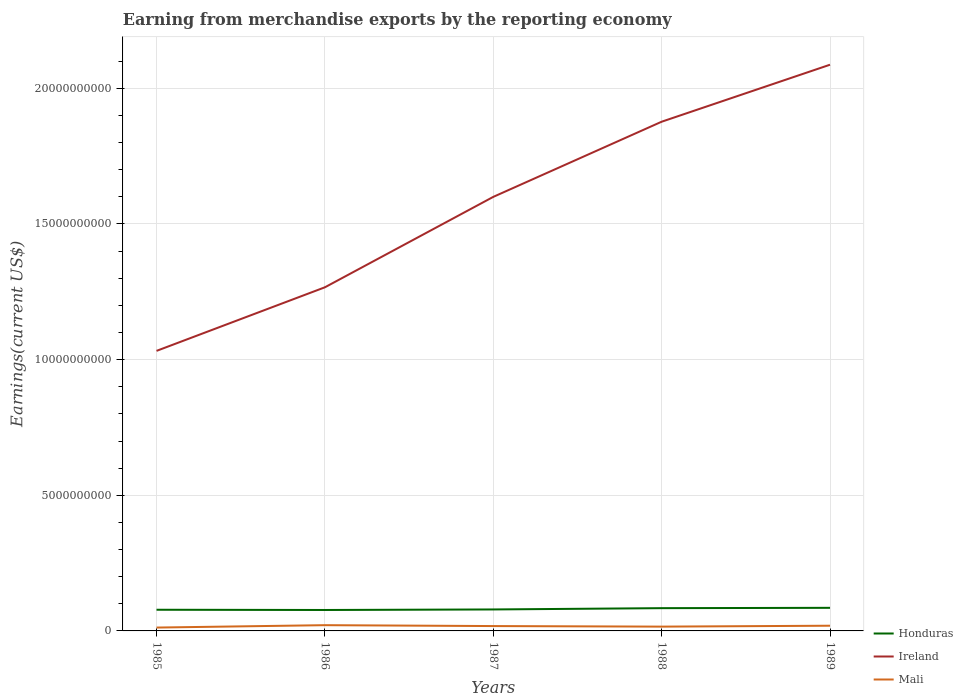Across all years, what is the maximum amount earned from merchandise exports in Ireland?
Provide a succinct answer. 1.03e+1. In which year was the amount earned from merchandise exports in Ireland maximum?
Ensure brevity in your answer.  1985. What is the total amount earned from merchandise exports in Honduras in the graph?
Provide a succinct answer. 8.28e+06. What is the difference between the highest and the second highest amount earned from merchandise exports in Mali?
Keep it short and to the point. 8.81e+07. What is the difference between the highest and the lowest amount earned from merchandise exports in Honduras?
Provide a succinct answer. 2. Is the amount earned from merchandise exports in Ireland strictly greater than the amount earned from merchandise exports in Honduras over the years?
Make the answer very short. No. How many lines are there?
Give a very brief answer. 3. What is the difference between two consecutive major ticks on the Y-axis?
Your response must be concise. 5.00e+09. Are the values on the major ticks of Y-axis written in scientific E-notation?
Your answer should be very brief. No. Does the graph contain any zero values?
Provide a short and direct response. No. Where does the legend appear in the graph?
Provide a succinct answer. Bottom right. How many legend labels are there?
Offer a very short reply. 3. What is the title of the graph?
Offer a very short reply. Earning from merchandise exports by the reporting economy. What is the label or title of the X-axis?
Make the answer very short. Years. What is the label or title of the Y-axis?
Your response must be concise. Earnings(current US$). What is the Earnings(current US$) of Honduras in 1985?
Offer a very short reply. 7.80e+08. What is the Earnings(current US$) of Ireland in 1985?
Your answer should be very brief. 1.03e+1. What is the Earnings(current US$) in Mali in 1985?
Your response must be concise. 1.24e+08. What is the Earnings(current US$) of Honduras in 1986?
Keep it short and to the point. 7.72e+08. What is the Earnings(current US$) in Ireland in 1986?
Your answer should be compact. 1.27e+1. What is the Earnings(current US$) in Mali in 1986?
Make the answer very short. 2.12e+08. What is the Earnings(current US$) of Honduras in 1987?
Keep it short and to the point. 7.91e+08. What is the Earnings(current US$) in Ireland in 1987?
Give a very brief answer. 1.60e+1. What is the Earnings(current US$) in Mali in 1987?
Provide a short and direct response. 1.79e+08. What is the Earnings(current US$) of Honduras in 1988?
Provide a succinct answer. 8.39e+08. What is the Earnings(current US$) of Ireland in 1988?
Make the answer very short. 1.88e+1. What is the Earnings(current US$) of Mali in 1988?
Give a very brief answer. 1.58e+08. What is the Earnings(current US$) of Honduras in 1989?
Offer a very short reply. 8.51e+08. What is the Earnings(current US$) of Ireland in 1989?
Keep it short and to the point. 2.09e+1. What is the Earnings(current US$) of Mali in 1989?
Ensure brevity in your answer.  1.92e+08. Across all years, what is the maximum Earnings(current US$) of Honduras?
Provide a short and direct response. 8.51e+08. Across all years, what is the maximum Earnings(current US$) in Ireland?
Your answer should be very brief. 2.09e+1. Across all years, what is the maximum Earnings(current US$) of Mali?
Give a very brief answer. 2.12e+08. Across all years, what is the minimum Earnings(current US$) of Honduras?
Provide a short and direct response. 7.72e+08. Across all years, what is the minimum Earnings(current US$) in Ireland?
Offer a terse response. 1.03e+1. Across all years, what is the minimum Earnings(current US$) in Mali?
Make the answer very short. 1.24e+08. What is the total Earnings(current US$) of Honduras in the graph?
Give a very brief answer. 4.03e+09. What is the total Earnings(current US$) of Ireland in the graph?
Make the answer very short. 7.86e+1. What is the total Earnings(current US$) in Mali in the graph?
Make the answer very short. 8.64e+08. What is the difference between the Earnings(current US$) of Honduras in 1985 and that in 1986?
Give a very brief answer. 8.28e+06. What is the difference between the Earnings(current US$) of Ireland in 1985 and that in 1986?
Provide a short and direct response. -2.34e+09. What is the difference between the Earnings(current US$) in Mali in 1985 and that in 1986?
Provide a succinct answer. -8.81e+07. What is the difference between the Earnings(current US$) in Honduras in 1985 and that in 1987?
Your response must be concise. -1.13e+07. What is the difference between the Earnings(current US$) in Ireland in 1985 and that in 1987?
Your response must be concise. -5.68e+09. What is the difference between the Earnings(current US$) of Mali in 1985 and that in 1987?
Give a very brief answer. -5.53e+07. What is the difference between the Earnings(current US$) of Honduras in 1985 and that in 1988?
Keep it short and to the point. -5.89e+07. What is the difference between the Earnings(current US$) in Ireland in 1985 and that in 1988?
Make the answer very short. -8.45e+09. What is the difference between the Earnings(current US$) in Mali in 1985 and that in 1988?
Your response must be concise. -3.46e+07. What is the difference between the Earnings(current US$) of Honduras in 1985 and that in 1989?
Provide a succinct answer. -7.09e+07. What is the difference between the Earnings(current US$) of Ireland in 1985 and that in 1989?
Provide a succinct answer. -1.05e+1. What is the difference between the Earnings(current US$) of Mali in 1985 and that in 1989?
Make the answer very short. -6.81e+07. What is the difference between the Earnings(current US$) of Honduras in 1986 and that in 1987?
Provide a short and direct response. -1.96e+07. What is the difference between the Earnings(current US$) of Ireland in 1986 and that in 1987?
Provide a short and direct response. -3.33e+09. What is the difference between the Earnings(current US$) in Mali in 1986 and that in 1987?
Keep it short and to the point. 3.28e+07. What is the difference between the Earnings(current US$) of Honduras in 1986 and that in 1988?
Offer a very short reply. -6.72e+07. What is the difference between the Earnings(current US$) of Ireland in 1986 and that in 1988?
Ensure brevity in your answer.  -6.10e+09. What is the difference between the Earnings(current US$) in Mali in 1986 and that in 1988?
Provide a short and direct response. 5.35e+07. What is the difference between the Earnings(current US$) in Honduras in 1986 and that in 1989?
Provide a succinct answer. -7.92e+07. What is the difference between the Earnings(current US$) of Ireland in 1986 and that in 1989?
Provide a short and direct response. -8.20e+09. What is the difference between the Earnings(current US$) in Mali in 1986 and that in 1989?
Offer a very short reply. 2.00e+07. What is the difference between the Earnings(current US$) in Honduras in 1987 and that in 1988?
Your answer should be compact. -4.76e+07. What is the difference between the Earnings(current US$) in Ireland in 1987 and that in 1988?
Your response must be concise. -2.77e+09. What is the difference between the Earnings(current US$) in Mali in 1987 and that in 1988?
Keep it short and to the point. 2.07e+07. What is the difference between the Earnings(current US$) in Honduras in 1987 and that in 1989?
Ensure brevity in your answer.  -5.96e+07. What is the difference between the Earnings(current US$) of Ireland in 1987 and that in 1989?
Give a very brief answer. -4.87e+09. What is the difference between the Earnings(current US$) of Mali in 1987 and that in 1989?
Your response must be concise. -1.28e+07. What is the difference between the Earnings(current US$) in Honduras in 1988 and that in 1989?
Provide a succinct answer. -1.20e+07. What is the difference between the Earnings(current US$) in Ireland in 1988 and that in 1989?
Ensure brevity in your answer.  -2.10e+09. What is the difference between the Earnings(current US$) of Mali in 1988 and that in 1989?
Provide a short and direct response. -3.35e+07. What is the difference between the Earnings(current US$) of Honduras in 1985 and the Earnings(current US$) of Ireland in 1986?
Your response must be concise. -1.19e+1. What is the difference between the Earnings(current US$) of Honduras in 1985 and the Earnings(current US$) of Mali in 1986?
Your response must be concise. 5.68e+08. What is the difference between the Earnings(current US$) of Ireland in 1985 and the Earnings(current US$) of Mali in 1986?
Your answer should be compact. 1.01e+1. What is the difference between the Earnings(current US$) of Honduras in 1985 and the Earnings(current US$) of Ireland in 1987?
Keep it short and to the point. -1.52e+1. What is the difference between the Earnings(current US$) of Honduras in 1985 and the Earnings(current US$) of Mali in 1987?
Give a very brief answer. 6.01e+08. What is the difference between the Earnings(current US$) of Ireland in 1985 and the Earnings(current US$) of Mali in 1987?
Provide a short and direct response. 1.01e+1. What is the difference between the Earnings(current US$) of Honduras in 1985 and the Earnings(current US$) of Ireland in 1988?
Provide a succinct answer. -1.80e+1. What is the difference between the Earnings(current US$) of Honduras in 1985 and the Earnings(current US$) of Mali in 1988?
Make the answer very short. 6.22e+08. What is the difference between the Earnings(current US$) of Ireland in 1985 and the Earnings(current US$) of Mali in 1988?
Your answer should be compact. 1.02e+1. What is the difference between the Earnings(current US$) in Honduras in 1985 and the Earnings(current US$) in Ireland in 1989?
Keep it short and to the point. -2.01e+1. What is the difference between the Earnings(current US$) in Honduras in 1985 and the Earnings(current US$) in Mali in 1989?
Provide a short and direct response. 5.88e+08. What is the difference between the Earnings(current US$) in Ireland in 1985 and the Earnings(current US$) in Mali in 1989?
Provide a succinct answer. 1.01e+1. What is the difference between the Earnings(current US$) of Honduras in 1986 and the Earnings(current US$) of Ireland in 1987?
Ensure brevity in your answer.  -1.52e+1. What is the difference between the Earnings(current US$) of Honduras in 1986 and the Earnings(current US$) of Mali in 1987?
Your answer should be very brief. 5.93e+08. What is the difference between the Earnings(current US$) in Ireland in 1986 and the Earnings(current US$) in Mali in 1987?
Offer a very short reply. 1.25e+1. What is the difference between the Earnings(current US$) of Honduras in 1986 and the Earnings(current US$) of Ireland in 1988?
Ensure brevity in your answer.  -1.80e+1. What is the difference between the Earnings(current US$) of Honduras in 1986 and the Earnings(current US$) of Mali in 1988?
Offer a very short reply. 6.14e+08. What is the difference between the Earnings(current US$) of Ireland in 1986 and the Earnings(current US$) of Mali in 1988?
Your response must be concise. 1.25e+1. What is the difference between the Earnings(current US$) of Honduras in 1986 and the Earnings(current US$) of Ireland in 1989?
Keep it short and to the point. -2.01e+1. What is the difference between the Earnings(current US$) of Honduras in 1986 and the Earnings(current US$) of Mali in 1989?
Ensure brevity in your answer.  5.80e+08. What is the difference between the Earnings(current US$) of Ireland in 1986 and the Earnings(current US$) of Mali in 1989?
Your answer should be very brief. 1.25e+1. What is the difference between the Earnings(current US$) in Honduras in 1987 and the Earnings(current US$) in Ireland in 1988?
Provide a short and direct response. -1.80e+1. What is the difference between the Earnings(current US$) in Honduras in 1987 and the Earnings(current US$) in Mali in 1988?
Keep it short and to the point. 6.33e+08. What is the difference between the Earnings(current US$) of Ireland in 1987 and the Earnings(current US$) of Mali in 1988?
Keep it short and to the point. 1.58e+1. What is the difference between the Earnings(current US$) in Honduras in 1987 and the Earnings(current US$) in Ireland in 1989?
Provide a succinct answer. -2.01e+1. What is the difference between the Earnings(current US$) in Honduras in 1987 and the Earnings(current US$) in Mali in 1989?
Provide a succinct answer. 6.00e+08. What is the difference between the Earnings(current US$) in Ireland in 1987 and the Earnings(current US$) in Mali in 1989?
Make the answer very short. 1.58e+1. What is the difference between the Earnings(current US$) in Honduras in 1988 and the Earnings(current US$) in Ireland in 1989?
Give a very brief answer. -2.00e+1. What is the difference between the Earnings(current US$) of Honduras in 1988 and the Earnings(current US$) of Mali in 1989?
Offer a terse response. 6.47e+08. What is the difference between the Earnings(current US$) in Ireland in 1988 and the Earnings(current US$) in Mali in 1989?
Your response must be concise. 1.86e+1. What is the average Earnings(current US$) in Honduras per year?
Keep it short and to the point. 8.07e+08. What is the average Earnings(current US$) in Ireland per year?
Make the answer very short. 1.57e+1. What is the average Earnings(current US$) in Mali per year?
Make the answer very short. 1.73e+08. In the year 1985, what is the difference between the Earnings(current US$) in Honduras and Earnings(current US$) in Ireland?
Ensure brevity in your answer.  -9.54e+09. In the year 1985, what is the difference between the Earnings(current US$) in Honduras and Earnings(current US$) in Mali?
Offer a terse response. 6.57e+08. In the year 1985, what is the difference between the Earnings(current US$) of Ireland and Earnings(current US$) of Mali?
Make the answer very short. 1.02e+1. In the year 1986, what is the difference between the Earnings(current US$) in Honduras and Earnings(current US$) in Ireland?
Your response must be concise. -1.19e+1. In the year 1986, what is the difference between the Earnings(current US$) in Honduras and Earnings(current US$) in Mali?
Your response must be concise. 5.60e+08. In the year 1986, what is the difference between the Earnings(current US$) in Ireland and Earnings(current US$) in Mali?
Your answer should be very brief. 1.25e+1. In the year 1987, what is the difference between the Earnings(current US$) of Honduras and Earnings(current US$) of Ireland?
Provide a succinct answer. -1.52e+1. In the year 1987, what is the difference between the Earnings(current US$) of Honduras and Earnings(current US$) of Mali?
Offer a very short reply. 6.12e+08. In the year 1987, what is the difference between the Earnings(current US$) of Ireland and Earnings(current US$) of Mali?
Offer a terse response. 1.58e+1. In the year 1988, what is the difference between the Earnings(current US$) in Honduras and Earnings(current US$) in Ireland?
Your answer should be very brief. -1.79e+1. In the year 1988, what is the difference between the Earnings(current US$) of Honduras and Earnings(current US$) of Mali?
Offer a very short reply. 6.81e+08. In the year 1988, what is the difference between the Earnings(current US$) in Ireland and Earnings(current US$) in Mali?
Your answer should be compact. 1.86e+1. In the year 1989, what is the difference between the Earnings(current US$) in Honduras and Earnings(current US$) in Ireland?
Your response must be concise. -2.00e+1. In the year 1989, what is the difference between the Earnings(current US$) of Honduras and Earnings(current US$) of Mali?
Your response must be concise. 6.59e+08. In the year 1989, what is the difference between the Earnings(current US$) of Ireland and Earnings(current US$) of Mali?
Provide a succinct answer. 2.07e+1. What is the ratio of the Earnings(current US$) of Honduras in 1985 to that in 1986?
Offer a very short reply. 1.01. What is the ratio of the Earnings(current US$) of Ireland in 1985 to that in 1986?
Your answer should be very brief. 0.81. What is the ratio of the Earnings(current US$) of Mali in 1985 to that in 1986?
Offer a very short reply. 0.58. What is the ratio of the Earnings(current US$) of Honduras in 1985 to that in 1987?
Your response must be concise. 0.99. What is the ratio of the Earnings(current US$) of Ireland in 1985 to that in 1987?
Provide a short and direct response. 0.65. What is the ratio of the Earnings(current US$) in Mali in 1985 to that in 1987?
Make the answer very short. 0.69. What is the ratio of the Earnings(current US$) of Honduras in 1985 to that in 1988?
Your answer should be compact. 0.93. What is the ratio of the Earnings(current US$) of Ireland in 1985 to that in 1988?
Provide a succinct answer. 0.55. What is the ratio of the Earnings(current US$) in Mali in 1985 to that in 1988?
Ensure brevity in your answer.  0.78. What is the ratio of the Earnings(current US$) of Honduras in 1985 to that in 1989?
Your answer should be very brief. 0.92. What is the ratio of the Earnings(current US$) in Ireland in 1985 to that in 1989?
Provide a short and direct response. 0.49. What is the ratio of the Earnings(current US$) of Mali in 1985 to that in 1989?
Your response must be concise. 0.64. What is the ratio of the Earnings(current US$) of Honduras in 1986 to that in 1987?
Keep it short and to the point. 0.98. What is the ratio of the Earnings(current US$) of Ireland in 1986 to that in 1987?
Ensure brevity in your answer.  0.79. What is the ratio of the Earnings(current US$) in Mali in 1986 to that in 1987?
Provide a succinct answer. 1.18. What is the ratio of the Earnings(current US$) of Honduras in 1986 to that in 1988?
Your answer should be compact. 0.92. What is the ratio of the Earnings(current US$) in Ireland in 1986 to that in 1988?
Provide a short and direct response. 0.67. What is the ratio of the Earnings(current US$) of Mali in 1986 to that in 1988?
Offer a terse response. 1.34. What is the ratio of the Earnings(current US$) of Honduras in 1986 to that in 1989?
Give a very brief answer. 0.91. What is the ratio of the Earnings(current US$) in Ireland in 1986 to that in 1989?
Give a very brief answer. 0.61. What is the ratio of the Earnings(current US$) of Mali in 1986 to that in 1989?
Provide a succinct answer. 1.1. What is the ratio of the Earnings(current US$) in Honduras in 1987 to that in 1988?
Your response must be concise. 0.94. What is the ratio of the Earnings(current US$) in Ireland in 1987 to that in 1988?
Provide a succinct answer. 0.85. What is the ratio of the Earnings(current US$) of Mali in 1987 to that in 1988?
Ensure brevity in your answer.  1.13. What is the ratio of the Earnings(current US$) in Ireland in 1987 to that in 1989?
Ensure brevity in your answer.  0.77. What is the ratio of the Earnings(current US$) of Honduras in 1988 to that in 1989?
Keep it short and to the point. 0.99. What is the ratio of the Earnings(current US$) in Ireland in 1988 to that in 1989?
Make the answer very short. 0.9. What is the ratio of the Earnings(current US$) in Mali in 1988 to that in 1989?
Provide a short and direct response. 0.83. What is the difference between the highest and the second highest Earnings(current US$) of Ireland?
Your response must be concise. 2.10e+09. What is the difference between the highest and the second highest Earnings(current US$) in Mali?
Make the answer very short. 2.00e+07. What is the difference between the highest and the lowest Earnings(current US$) in Honduras?
Your answer should be compact. 7.92e+07. What is the difference between the highest and the lowest Earnings(current US$) in Ireland?
Offer a terse response. 1.05e+1. What is the difference between the highest and the lowest Earnings(current US$) of Mali?
Keep it short and to the point. 8.81e+07. 